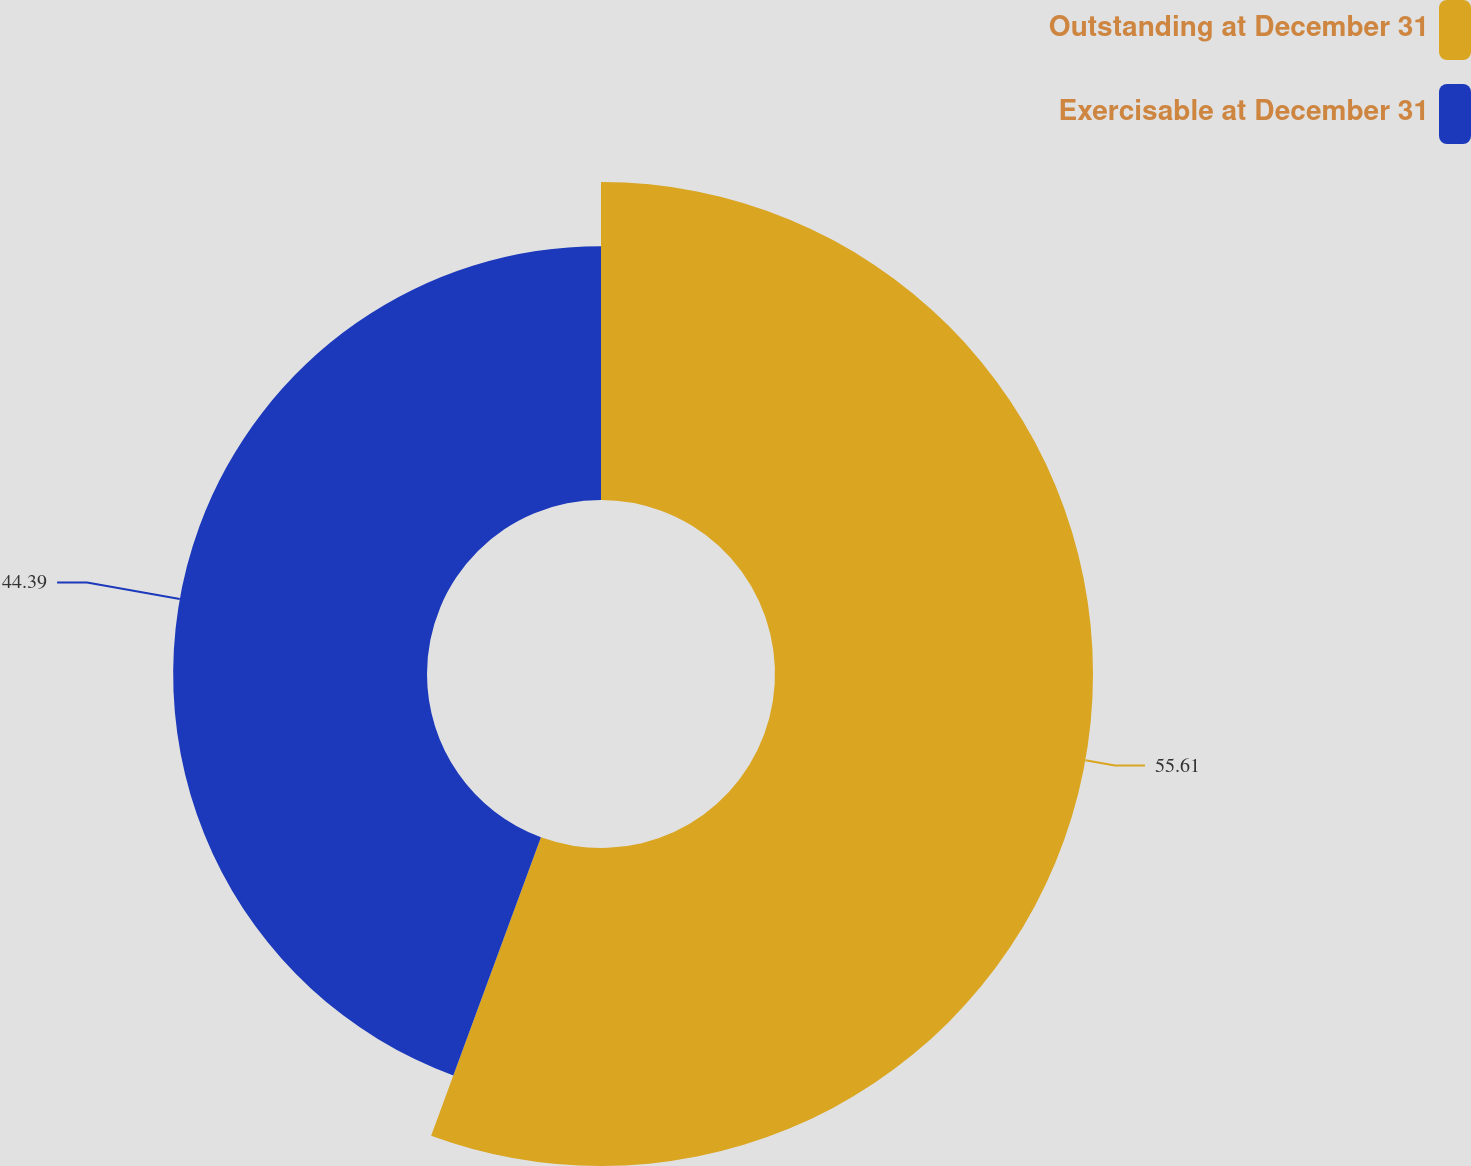Convert chart. <chart><loc_0><loc_0><loc_500><loc_500><pie_chart><fcel>Outstanding at December 31<fcel>Exercisable at December 31<nl><fcel>55.61%<fcel>44.39%<nl></chart> 